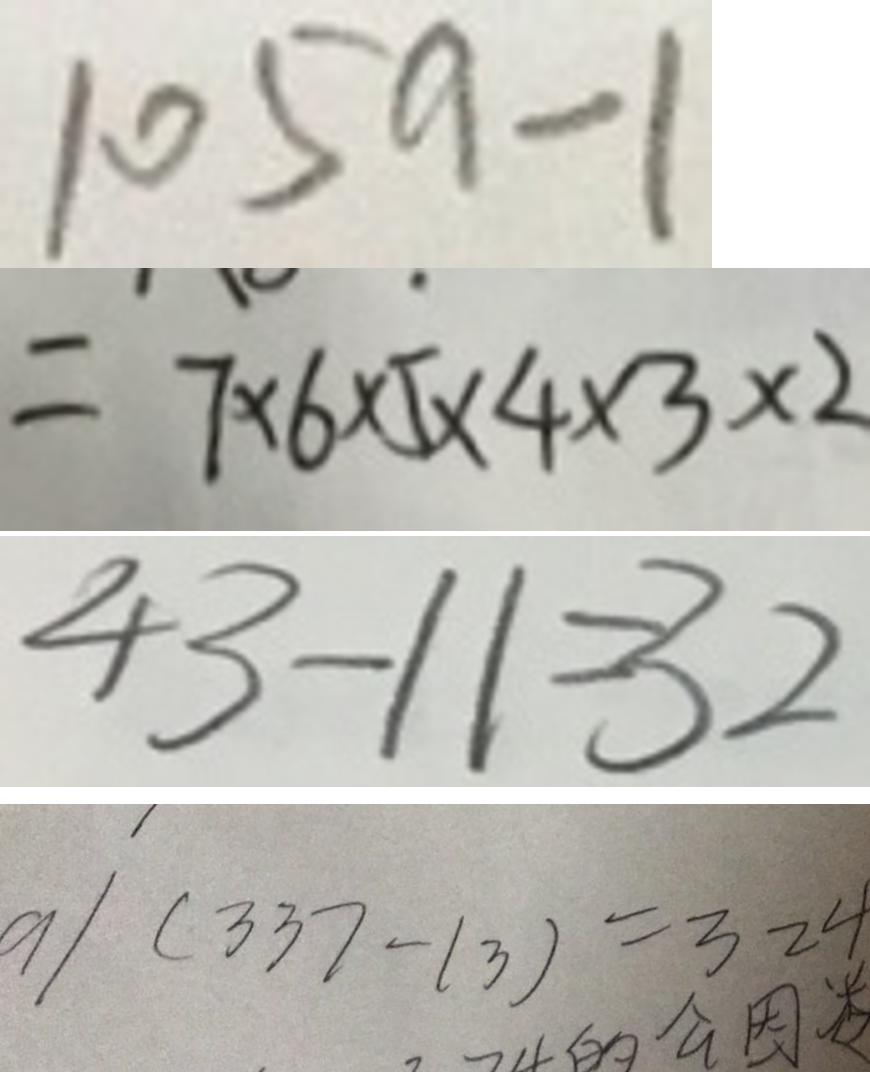Convert formula to latex. <formula><loc_0><loc_0><loc_500><loc_500>1 0 5 9 - 1 
 = 7 \times 6 \times 5 \times 4 \times 3 \times 2 
 4 3 - 1 1 = 3 2 
 a \vert ( 3 3 7 - 1 3 ) = 3 2 4</formula> 